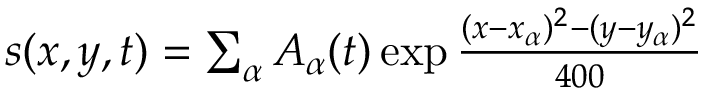<formula> <loc_0><loc_0><loc_500><loc_500>\begin{array} { r } { s ( x , y , t ) = \sum _ { \alpha } A _ { \alpha } ( t ) \exp { \frac { ( x - x _ { \alpha } ) ^ { 2 } - ( y - y _ { \alpha } ) ^ { 2 } } { 4 0 0 } } } \end{array}</formula> 